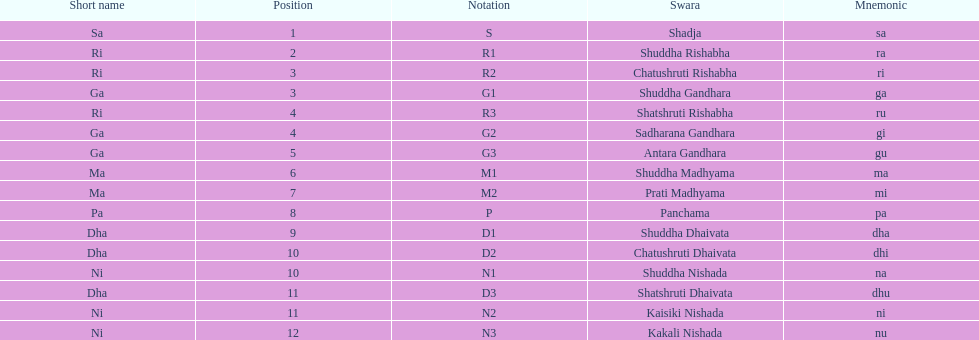Other than m1 how many notations have "1" in them? 4. 